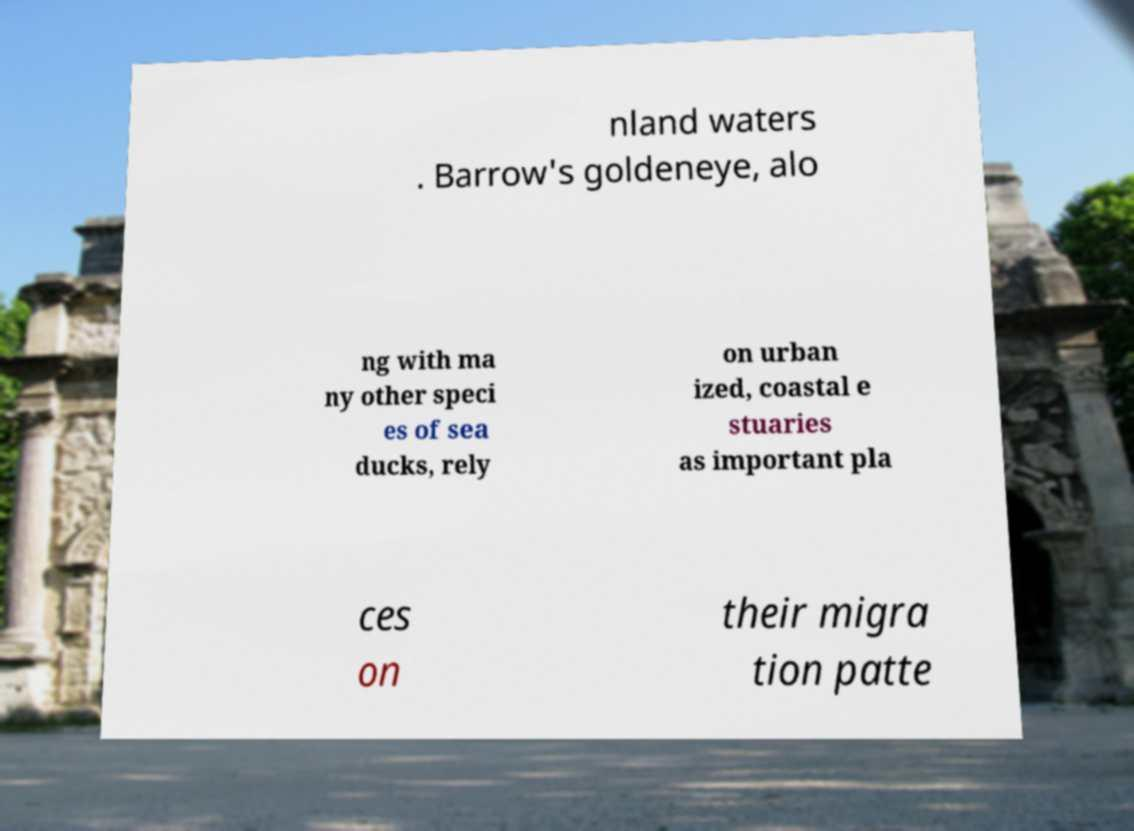Can you accurately transcribe the text from the provided image for me? nland waters . Barrow's goldeneye, alo ng with ma ny other speci es of sea ducks, rely on urban ized, coastal e stuaries as important pla ces on their migra tion patte 